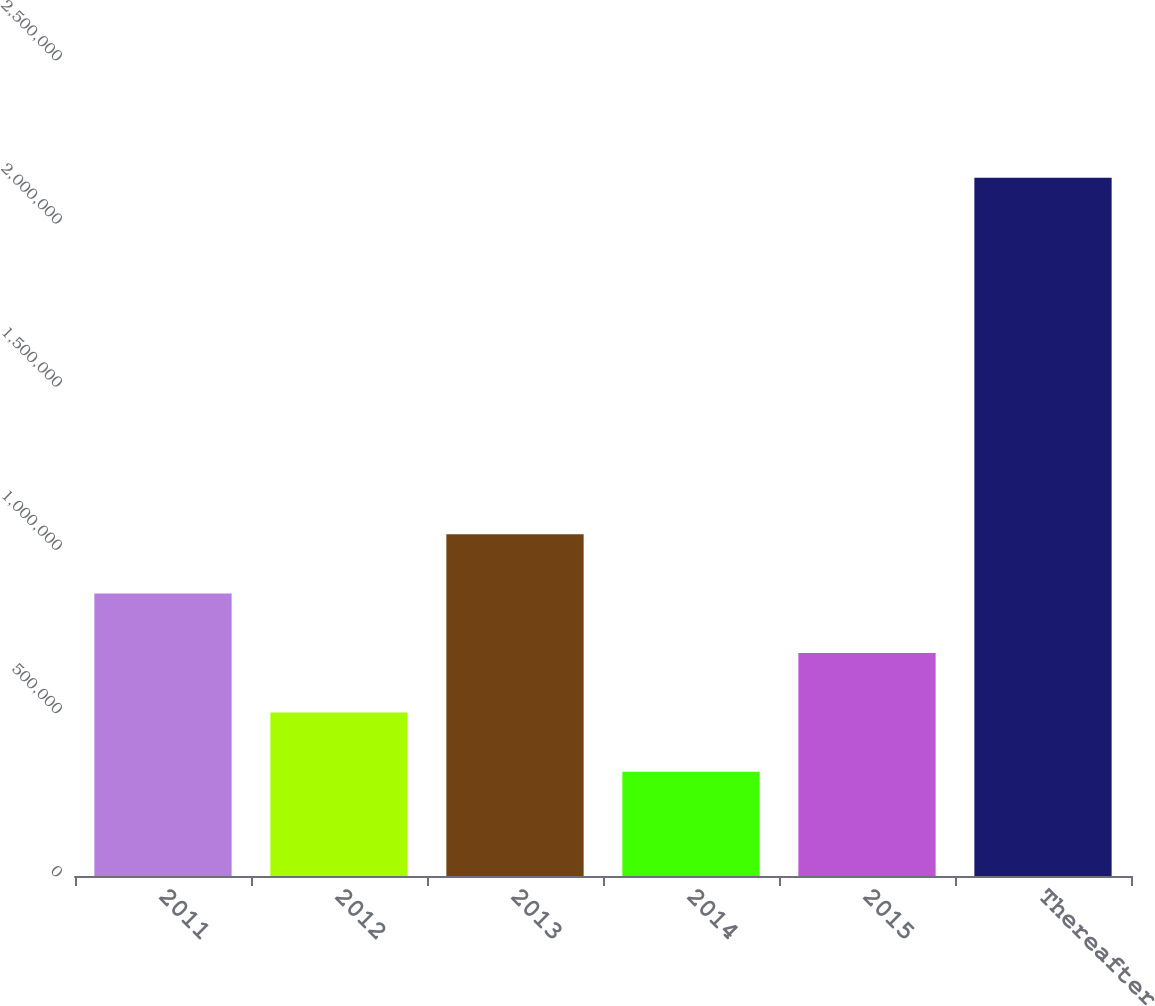Convert chart to OTSL. <chart><loc_0><loc_0><loc_500><loc_500><bar_chart><fcel>2011<fcel>2012<fcel>2013<fcel>2014<fcel>2015<fcel>Thereafter<nl><fcel>865264<fcel>501188<fcel>1.0473e+06<fcel>319150<fcel>683226<fcel>2.13953e+06<nl></chart> 